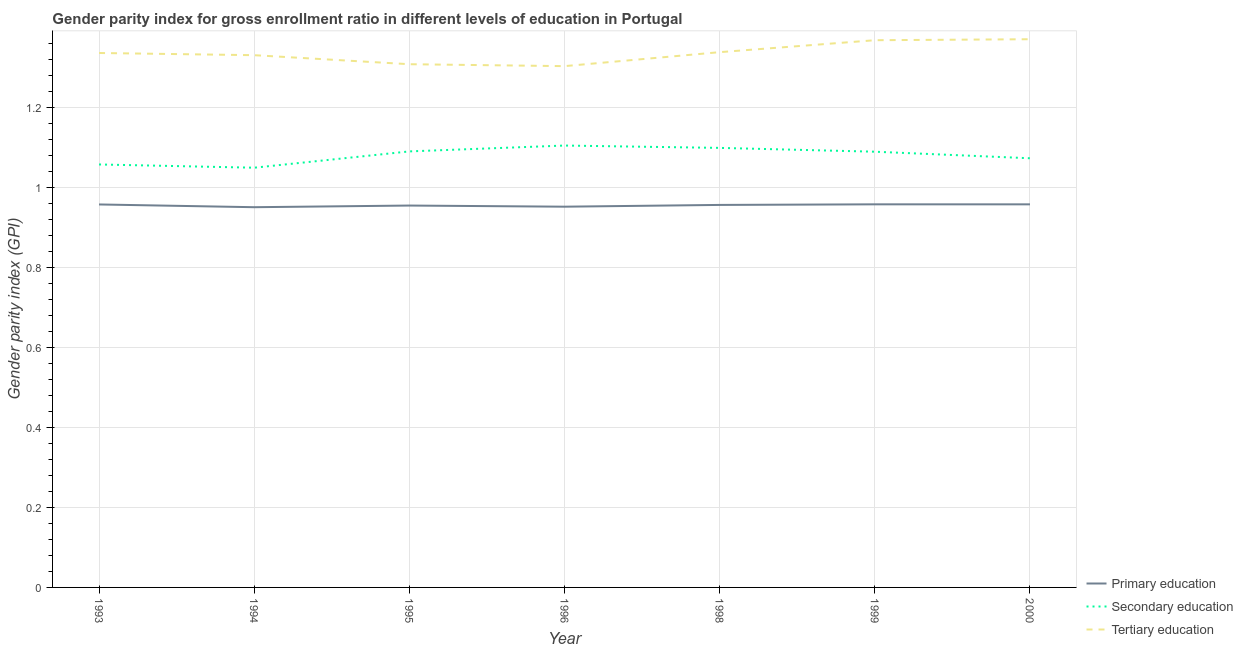How many different coloured lines are there?
Offer a very short reply. 3. Does the line corresponding to gender parity index in secondary education intersect with the line corresponding to gender parity index in tertiary education?
Offer a terse response. No. What is the gender parity index in tertiary education in 1998?
Make the answer very short. 1.34. Across all years, what is the maximum gender parity index in tertiary education?
Offer a terse response. 1.37. Across all years, what is the minimum gender parity index in tertiary education?
Your answer should be very brief. 1.3. In which year was the gender parity index in secondary education minimum?
Offer a very short reply. 1994. What is the total gender parity index in primary education in the graph?
Keep it short and to the point. 6.68. What is the difference between the gender parity index in primary education in 1993 and that in 1995?
Your answer should be compact. 0. What is the difference between the gender parity index in tertiary education in 1999 and the gender parity index in primary education in 1998?
Your response must be concise. 0.41. What is the average gender parity index in secondary education per year?
Make the answer very short. 1.08. In the year 1999, what is the difference between the gender parity index in primary education and gender parity index in secondary education?
Provide a succinct answer. -0.13. In how many years, is the gender parity index in secondary education greater than 0.4?
Provide a succinct answer. 7. What is the ratio of the gender parity index in secondary education in 1993 to that in 2000?
Offer a very short reply. 0.99. Is the difference between the gender parity index in tertiary education in 1994 and 1999 greater than the difference between the gender parity index in primary education in 1994 and 1999?
Provide a short and direct response. No. What is the difference between the highest and the second highest gender parity index in primary education?
Offer a very short reply. 1.0013580321932558e-5. What is the difference between the highest and the lowest gender parity index in secondary education?
Provide a succinct answer. 0.06. In how many years, is the gender parity index in primary education greater than the average gender parity index in primary education taken over all years?
Offer a very short reply. 4. Is the gender parity index in tertiary education strictly greater than the gender parity index in secondary education over the years?
Offer a very short reply. Yes. How many lines are there?
Your response must be concise. 3. Does the graph contain any zero values?
Offer a terse response. No. Does the graph contain grids?
Give a very brief answer. Yes. What is the title of the graph?
Provide a short and direct response. Gender parity index for gross enrollment ratio in different levels of education in Portugal. What is the label or title of the X-axis?
Ensure brevity in your answer.  Year. What is the label or title of the Y-axis?
Give a very brief answer. Gender parity index (GPI). What is the Gender parity index (GPI) in Primary education in 1993?
Ensure brevity in your answer.  0.96. What is the Gender parity index (GPI) in Secondary education in 1993?
Your response must be concise. 1.06. What is the Gender parity index (GPI) of Tertiary education in 1993?
Give a very brief answer. 1.34. What is the Gender parity index (GPI) of Primary education in 1994?
Give a very brief answer. 0.95. What is the Gender parity index (GPI) of Secondary education in 1994?
Offer a very short reply. 1.05. What is the Gender parity index (GPI) in Tertiary education in 1994?
Ensure brevity in your answer.  1.33. What is the Gender parity index (GPI) of Primary education in 1995?
Offer a very short reply. 0.95. What is the Gender parity index (GPI) of Secondary education in 1995?
Offer a terse response. 1.09. What is the Gender parity index (GPI) of Tertiary education in 1995?
Your answer should be compact. 1.31. What is the Gender parity index (GPI) of Primary education in 1996?
Give a very brief answer. 0.95. What is the Gender parity index (GPI) of Secondary education in 1996?
Your answer should be very brief. 1.1. What is the Gender parity index (GPI) in Tertiary education in 1996?
Ensure brevity in your answer.  1.3. What is the Gender parity index (GPI) in Primary education in 1998?
Make the answer very short. 0.96. What is the Gender parity index (GPI) of Secondary education in 1998?
Keep it short and to the point. 1.1. What is the Gender parity index (GPI) of Tertiary education in 1998?
Your response must be concise. 1.34. What is the Gender parity index (GPI) in Primary education in 1999?
Make the answer very short. 0.96. What is the Gender parity index (GPI) in Secondary education in 1999?
Offer a terse response. 1.09. What is the Gender parity index (GPI) in Tertiary education in 1999?
Give a very brief answer. 1.37. What is the Gender parity index (GPI) of Primary education in 2000?
Your answer should be very brief. 0.96. What is the Gender parity index (GPI) of Secondary education in 2000?
Provide a succinct answer. 1.07. What is the Gender parity index (GPI) of Tertiary education in 2000?
Your answer should be very brief. 1.37. Across all years, what is the maximum Gender parity index (GPI) of Primary education?
Provide a succinct answer. 0.96. Across all years, what is the maximum Gender parity index (GPI) in Secondary education?
Provide a short and direct response. 1.1. Across all years, what is the maximum Gender parity index (GPI) of Tertiary education?
Provide a succinct answer. 1.37. Across all years, what is the minimum Gender parity index (GPI) of Primary education?
Your answer should be very brief. 0.95. Across all years, what is the minimum Gender parity index (GPI) in Secondary education?
Your answer should be very brief. 1.05. Across all years, what is the minimum Gender parity index (GPI) of Tertiary education?
Offer a very short reply. 1.3. What is the total Gender parity index (GPI) of Primary education in the graph?
Keep it short and to the point. 6.68. What is the total Gender parity index (GPI) of Secondary education in the graph?
Make the answer very short. 7.56. What is the total Gender parity index (GPI) of Tertiary education in the graph?
Your answer should be very brief. 9.35. What is the difference between the Gender parity index (GPI) in Primary education in 1993 and that in 1994?
Your answer should be very brief. 0.01. What is the difference between the Gender parity index (GPI) of Secondary education in 1993 and that in 1994?
Offer a terse response. 0.01. What is the difference between the Gender parity index (GPI) of Tertiary education in 1993 and that in 1994?
Offer a very short reply. 0.01. What is the difference between the Gender parity index (GPI) of Primary education in 1993 and that in 1995?
Make the answer very short. 0. What is the difference between the Gender parity index (GPI) of Secondary education in 1993 and that in 1995?
Make the answer very short. -0.03. What is the difference between the Gender parity index (GPI) of Tertiary education in 1993 and that in 1995?
Ensure brevity in your answer.  0.03. What is the difference between the Gender parity index (GPI) in Primary education in 1993 and that in 1996?
Ensure brevity in your answer.  0.01. What is the difference between the Gender parity index (GPI) of Secondary education in 1993 and that in 1996?
Your answer should be compact. -0.05. What is the difference between the Gender parity index (GPI) of Tertiary education in 1993 and that in 1996?
Give a very brief answer. 0.03. What is the difference between the Gender parity index (GPI) of Primary education in 1993 and that in 1998?
Give a very brief answer. 0. What is the difference between the Gender parity index (GPI) of Secondary education in 1993 and that in 1998?
Your response must be concise. -0.04. What is the difference between the Gender parity index (GPI) in Tertiary education in 1993 and that in 1998?
Ensure brevity in your answer.  -0. What is the difference between the Gender parity index (GPI) of Primary education in 1993 and that in 1999?
Provide a succinct answer. -0. What is the difference between the Gender parity index (GPI) of Secondary education in 1993 and that in 1999?
Keep it short and to the point. -0.03. What is the difference between the Gender parity index (GPI) in Tertiary education in 1993 and that in 1999?
Offer a very short reply. -0.03. What is the difference between the Gender parity index (GPI) in Primary education in 1993 and that in 2000?
Ensure brevity in your answer.  -0. What is the difference between the Gender parity index (GPI) of Secondary education in 1993 and that in 2000?
Offer a terse response. -0.02. What is the difference between the Gender parity index (GPI) in Tertiary education in 1993 and that in 2000?
Your response must be concise. -0.03. What is the difference between the Gender parity index (GPI) of Primary education in 1994 and that in 1995?
Ensure brevity in your answer.  -0. What is the difference between the Gender parity index (GPI) of Secondary education in 1994 and that in 1995?
Provide a short and direct response. -0.04. What is the difference between the Gender parity index (GPI) in Tertiary education in 1994 and that in 1995?
Keep it short and to the point. 0.02. What is the difference between the Gender parity index (GPI) of Primary education in 1994 and that in 1996?
Provide a succinct answer. -0. What is the difference between the Gender parity index (GPI) in Secondary education in 1994 and that in 1996?
Keep it short and to the point. -0.06. What is the difference between the Gender parity index (GPI) in Tertiary education in 1994 and that in 1996?
Your answer should be compact. 0.03. What is the difference between the Gender parity index (GPI) in Primary education in 1994 and that in 1998?
Keep it short and to the point. -0.01. What is the difference between the Gender parity index (GPI) of Secondary education in 1994 and that in 1998?
Your response must be concise. -0.05. What is the difference between the Gender parity index (GPI) in Tertiary education in 1994 and that in 1998?
Make the answer very short. -0.01. What is the difference between the Gender parity index (GPI) of Primary education in 1994 and that in 1999?
Ensure brevity in your answer.  -0.01. What is the difference between the Gender parity index (GPI) of Secondary education in 1994 and that in 1999?
Your answer should be compact. -0.04. What is the difference between the Gender parity index (GPI) of Tertiary education in 1994 and that in 1999?
Ensure brevity in your answer.  -0.04. What is the difference between the Gender parity index (GPI) of Primary education in 1994 and that in 2000?
Your response must be concise. -0.01. What is the difference between the Gender parity index (GPI) in Secondary education in 1994 and that in 2000?
Make the answer very short. -0.02. What is the difference between the Gender parity index (GPI) of Tertiary education in 1994 and that in 2000?
Provide a succinct answer. -0.04. What is the difference between the Gender parity index (GPI) of Primary education in 1995 and that in 1996?
Offer a terse response. 0. What is the difference between the Gender parity index (GPI) of Secondary education in 1995 and that in 1996?
Offer a very short reply. -0.01. What is the difference between the Gender parity index (GPI) of Tertiary education in 1995 and that in 1996?
Offer a very short reply. 0. What is the difference between the Gender parity index (GPI) in Primary education in 1995 and that in 1998?
Provide a succinct answer. -0. What is the difference between the Gender parity index (GPI) of Secondary education in 1995 and that in 1998?
Ensure brevity in your answer.  -0.01. What is the difference between the Gender parity index (GPI) in Tertiary education in 1995 and that in 1998?
Your answer should be compact. -0.03. What is the difference between the Gender parity index (GPI) of Primary education in 1995 and that in 1999?
Keep it short and to the point. -0. What is the difference between the Gender parity index (GPI) of Secondary education in 1995 and that in 1999?
Ensure brevity in your answer.  0. What is the difference between the Gender parity index (GPI) of Tertiary education in 1995 and that in 1999?
Give a very brief answer. -0.06. What is the difference between the Gender parity index (GPI) in Primary education in 1995 and that in 2000?
Your answer should be very brief. -0. What is the difference between the Gender parity index (GPI) of Secondary education in 1995 and that in 2000?
Provide a succinct answer. 0.02. What is the difference between the Gender parity index (GPI) in Tertiary education in 1995 and that in 2000?
Offer a very short reply. -0.06. What is the difference between the Gender parity index (GPI) of Primary education in 1996 and that in 1998?
Your response must be concise. -0. What is the difference between the Gender parity index (GPI) in Secondary education in 1996 and that in 1998?
Provide a short and direct response. 0.01. What is the difference between the Gender parity index (GPI) of Tertiary education in 1996 and that in 1998?
Ensure brevity in your answer.  -0.03. What is the difference between the Gender parity index (GPI) in Primary education in 1996 and that in 1999?
Provide a short and direct response. -0.01. What is the difference between the Gender parity index (GPI) in Secondary education in 1996 and that in 1999?
Your answer should be compact. 0.02. What is the difference between the Gender parity index (GPI) of Tertiary education in 1996 and that in 1999?
Offer a very short reply. -0.06. What is the difference between the Gender parity index (GPI) in Primary education in 1996 and that in 2000?
Offer a very short reply. -0.01. What is the difference between the Gender parity index (GPI) in Secondary education in 1996 and that in 2000?
Your response must be concise. 0.03. What is the difference between the Gender parity index (GPI) of Tertiary education in 1996 and that in 2000?
Keep it short and to the point. -0.07. What is the difference between the Gender parity index (GPI) of Primary education in 1998 and that in 1999?
Ensure brevity in your answer.  -0. What is the difference between the Gender parity index (GPI) in Secondary education in 1998 and that in 1999?
Your response must be concise. 0.01. What is the difference between the Gender parity index (GPI) of Tertiary education in 1998 and that in 1999?
Your answer should be very brief. -0.03. What is the difference between the Gender parity index (GPI) of Primary education in 1998 and that in 2000?
Offer a terse response. -0. What is the difference between the Gender parity index (GPI) in Secondary education in 1998 and that in 2000?
Offer a very short reply. 0.03. What is the difference between the Gender parity index (GPI) in Tertiary education in 1998 and that in 2000?
Your response must be concise. -0.03. What is the difference between the Gender parity index (GPI) in Secondary education in 1999 and that in 2000?
Your answer should be compact. 0.02. What is the difference between the Gender parity index (GPI) of Tertiary education in 1999 and that in 2000?
Your response must be concise. -0. What is the difference between the Gender parity index (GPI) in Primary education in 1993 and the Gender parity index (GPI) in Secondary education in 1994?
Provide a short and direct response. -0.09. What is the difference between the Gender parity index (GPI) of Primary education in 1993 and the Gender parity index (GPI) of Tertiary education in 1994?
Provide a short and direct response. -0.37. What is the difference between the Gender parity index (GPI) of Secondary education in 1993 and the Gender parity index (GPI) of Tertiary education in 1994?
Provide a short and direct response. -0.27. What is the difference between the Gender parity index (GPI) in Primary education in 1993 and the Gender parity index (GPI) in Secondary education in 1995?
Your answer should be compact. -0.13. What is the difference between the Gender parity index (GPI) of Primary education in 1993 and the Gender parity index (GPI) of Tertiary education in 1995?
Make the answer very short. -0.35. What is the difference between the Gender parity index (GPI) of Secondary education in 1993 and the Gender parity index (GPI) of Tertiary education in 1995?
Give a very brief answer. -0.25. What is the difference between the Gender parity index (GPI) in Primary education in 1993 and the Gender parity index (GPI) in Secondary education in 1996?
Your response must be concise. -0.15. What is the difference between the Gender parity index (GPI) of Primary education in 1993 and the Gender parity index (GPI) of Tertiary education in 1996?
Keep it short and to the point. -0.35. What is the difference between the Gender parity index (GPI) in Secondary education in 1993 and the Gender parity index (GPI) in Tertiary education in 1996?
Your answer should be compact. -0.25. What is the difference between the Gender parity index (GPI) in Primary education in 1993 and the Gender parity index (GPI) in Secondary education in 1998?
Your response must be concise. -0.14. What is the difference between the Gender parity index (GPI) in Primary education in 1993 and the Gender parity index (GPI) in Tertiary education in 1998?
Your answer should be very brief. -0.38. What is the difference between the Gender parity index (GPI) in Secondary education in 1993 and the Gender parity index (GPI) in Tertiary education in 1998?
Provide a succinct answer. -0.28. What is the difference between the Gender parity index (GPI) of Primary education in 1993 and the Gender parity index (GPI) of Secondary education in 1999?
Offer a very short reply. -0.13. What is the difference between the Gender parity index (GPI) of Primary education in 1993 and the Gender parity index (GPI) of Tertiary education in 1999?
Offer a very short reply. -0.41. What is the difference between the Gender parity index (GPI) of Secondary education in 1993 and the Gender parity index (GPI) of Tertiary education in 1999?
Your response must be concise. -0.31. What is the difference between the Gender parity index (GPI) in Primary education in 1993 and the Gender parity index (GPI) in Secondary education in 2000?
Provide a short and direct response. -0.12. What is the difference between the Gender parity index (GPI) of Primary education in 1993 and the Gender parity index (GPI) of Tertiary education in 2000?
Your response must be concise. -0.41. What is the difference between the Gender parity index (GPI) of Secondary education in 1993 and the Gender parity index (GPI) of Tertiary education in 2000?
Offer a very short reply. -0.31. What is the difference between the Gender parity index (GPI) in Primary education in 1994 and the Gender parity index (GPI) in Secondary education in 1995?
Ensure brevity in your answer.  -0.14. What is the difference between the Gender parity index (GPI) in Primary education in 1994 and the Gender parity index (GPI) in Tertiary education in 1995?
Your answer should be compact. -0.36. What is the difference between the Gender parity index (GPI) in Secondary education in 1994 and the Gender parity index (GPI) in Tertiary education in 1995?
Keep it short and to the point. -0.26. What is the difference between the Gender parity index (GPI) in Primary education in 1994 and the Gender parity index (GPI) in Secondary education in 1996?
Your answer should be compact. -0.15. What is the difference between the Gender parity index (GPI) in Primary education in 1994 and the Gender parity index (GPI) in Tertiary education in 1996?
Your answer should be very brief. -0.35. What is the difference between the Gender parity index (GPI) in Secondary education in 1994 and the Gender parity index (GPI) in Tertiary education in 1996?
Provide a short and direct response. -0.25. What is the difference between the Gender parity index (GPI) in Primary education in 1994 and the Gender parity index (GPI) in Secondary education in 1998?
Provide a short and direct response. -0.15. What is the difference between the Gender parity index (GPI) in Primary education in 1994 and the Gender parity index (GPI) in Tertiary education in 1998?
Your answer should be compact. -0.39. What is the difference between the Gender parity index (GPI) of Secondary education in 1994 and the Gender parity index (GPI) of Tertiary education in 1998?
Make the answer very short. -0.29. What is the difference between the Gender parity index (GPI) in Primary education in 1994 and the Gender parity index (GPI) in Secondary education in 1999?
Keep it short and to the point. -0.14. What is the difference between the Gender parity index (GPI) in Primary education in 1994 and the Gender parity index (GPI) in Tertiary education in 1999?
Provide a succinct answer. -0.42. What is the difference between the Gender parity index (GPI) of Secondary education in 1994 and the Gender parity index (GPI) of Tertiary education in 1999?
Keep it short and to the point. -0.32. What is the difference between the Gender parity index (GPI) of Primary education in 1994 and the Gender parity index (GPI) of Secondary education in 2000?
Offer a terse response. -0.12. What is the difference between the Gender parity index (GPI) of Primary education in 1994 and the Gender parity index (GPI) of Tertiary education in 2000?
Offer a terse response. -0.42. What is the difference between the Gender parity index (GPI) of Secondary education in 1994 and the Gender parity index (GPI) of Tertiary education in 2000?
Provide a succinct answer. -0.32. What is the difference between the Gender parity index (GPI) in Primary education in 1995 and the Gender parity index (GPI) in Secondary education in 1996?
Give a very brief answer. -0.15. What is the difference between the Gender parity index (GPI) of Primary education in 1995 and the Gender parity index (GPI) of Tertiary education in 1996?
Keep it short and to the point. -0.35. What is the difference between the Gender parity index (GPI) in Secondary education in 1995 and the Gender parity index (GPI) in Tertiary education in 1996?
Provide a succinct answer. -0.21. What is the difference between the Gender parity index (GPI) in Primary education in 1995 and the Gender parity index (GPI) in Secondary education in 1998?
Ensure brevity in your answer.  -0.14. What is the difference between the Gender parity index (GPI) of Primary education in 1995 and the Gender parity index (GPI) of Tertiary education in 1998?
Make the answer very short. -0.38. What is the difference between the Gender parity index (GPI) in Secondary education in 1995 and the Gender parity index (GPI) in Tertiary education in 1998?
Ensure brevity in your answer.  -0.25. What is the difference between the Gender parity index (GPI) of Primary education in 1995 and the Gender parity index (GPI) of Secondary education in 1999?
Your answer should be compact. -0.13. What is the difference between the Gender parity index (GPI) of Primary education in 1995 and the Gender parity index (GPI) of Tertiary education in 1999?
Provide a succinct answer. -0.41. What is the difference between the Gender parity index (GPI) of Secondary education in 1995 and the Gender parity index (GPI) of Tertiary education in 1999?
Give a very brief answer. -0.28. What is the difference between the Gender parity index (GPI) of Primary education in 1995 and the Gender parity index (GPI) of Secondary education in 2000?
Offer a terse response. -0.12. What is the difference between the Gender parity index (GPI) in Primary education in 1995 and the Gender parity index (GPI) in Tertiary education in 2000?
Give a very brief answer. -0.42. What is the difference between the Gender parity index (GPI) of Secondary education in 1995 and the Gender parity index (GPI) of Tertiary education in 2000?
Your answer should be very brief. -0.28. What is the difference between the Gender parity index (GPI) of Primary education in 1996 and the Gender parity index (GPI) of Secondary education in 1998?
Keep it short and to the point. -0.15. What is the difference between the Gender parity index (GPI) in Primary education in 1996 and the Gender parity index (GPI) in Tertiary education in 1998?
Offer a very short reply. -0.39. What is the difference between the Gender parity index (GPI) in Secondary education in 1996 and the Gender parity index (GPI) in Tertiary education in 1998?
Make the answer very short. -0.23. What is the difference between the Gender parity index (GPI) of Primary education in 1996 and the Gender parity index (GPI) of Secondary education in 1999?
Give a very brief answer. -0.14. What is the difference between the Gender parity index (GPI) of Primary education in 1996 and the Gender parity index (GPI) of Tertiary education in 1999?
Offer a terse response. -0.42. What is the difference between the Gender parity index (GPI) in Secondary education in 1996 and the Gender parity index (GPI) in Tertiary education in 1999?
Provide a short and direct response. -0.26. What is the difference between the Gender parity index (GPI) of Primary education in 1996 and the Gender parity index (GPI) of Secondary education in 2000?
Make the answer very short. -0.12. What is the difference between the Gender parity index (GPI) in Primary education in 1996 and the Gender parity index (GPI) in Tertiary education in 2000?
Keep it short and to the point. -0.42. What is the difference between the Gender parity index (GPI) of Secondary education in 1996 and the Gender parity index (GPI) of Tertiary education in 2000?
Your response must be concise. -0.27. What is the difference between the Gender parity index (GPI) of Primary education in 1998 and the Gender parity index (GPI) of Secondary education in 1999?
Offer a very short reply. -0.13. What is the difference between the Gender parity index (GPI) of Primary education in 1998 and the Gender parity index (GPI) of Tertiary education in 1999?
Provide a short and direct response. -0.41. What is the difference between the Gender parity index (GPI) of Secondary education in 1998 and the Gender parity index (GPI) of Tertiary education in 1999?
Offer a terse response. -0.27. What is the difference between the Gender parity index (GPI) in Primary education in 1998 and the Gender parity index (GPI) in Secondary education in 2000?
Offer a terse response. -0.12. What is the difference between the Gender parity index (GPI) in Primary education in 1998 and the Gender parity index (GPI) in Tertiary education in 2000?
Give a very brief answer. -0.41. What is the difference between the Gender parity index (GPI) in Secondary education in 1998 and the Gender parity index (GPI) in Tertiary education in 2000?
Offer a very short reply. -0.27. What is the difference between the Gender parity index (GPI) in Primary education in 1999 and the Gender parity index (GPI) in Secondary education in 2000?
Provide a short and direct response. -0.12. What is the difference between the Gender parity index (GPI) of Primary education in 1999 and the Gender parity index (GPI) of Tertiary education in 2000?
Provide a short and direct response. -0.41. What is the difference between the Gender parity index (GPI) of Secondary education in 1999 and the Gender parity index (GPI) of Tertiary education in 2000?
Keep it short and to the point. -0.28. What is the average Gender parity index (GPI) in Primary education per year?
Provide a succinct answer. 0.95. What is the average Gender parity index (GPI) of Secondary education per year?
Provide a succinct answer. 1.08. What is the average Gender parity index (GPI) in Tertiary education per year?
Offer a very short reply. 1.34. In the year 1993, what is the difference between the Gender parity index (GPI) in Primary education and Gender parity index (GPI) in Secondary education?
Provide a short and direct response. -0.1. In the year 1993, what is the difference between the Gender parity index (GPI) of Primary education and Gender parity index (GPI) of Tertiary education?
Provide a short and direct response. -0.38. In the year 1993, what is the difference between the Gender parity index (GPI) in Secondary education and Gender parity index (GPI) in Tertiary education?
Your answer should be very brief. -0.28. In the year 1994, what is the difference between the Gender parity index (GPI) in Primary education and Gender parity index (GPI) in Secondary education?
Provide a short and direct response. -0.1. In the year 1994, what is the difference between the Gender parity index (GPI) of Primary education and Gender parity index (GPI) of Tertiary education?
Your response must be concise. -0.38. In the year 1994, what is the difference between the Gender parity index (GPI) in Secondary education and Gender parity index (GPI) in Tertiary education?
Offer a terse response. -0.28. In the year 1995, what is the difference between the Gender parity index (GPI) of Primary education and Gender parity index (GPI) of Secondary education?
Your answer should be very brief. -0.14. In the year 1995, what is the difference between the Gender parity index (GPI) of Primary education and Gender parity index (GPI) of Tertiary education?
Make the answer very short. -0.35. In the year 1995, what is the difference between the Gender parity index (GPI) in Secondary education and Gender parity index (GPI) in Tertiary education?
Provide a succinct answer. -0.22. In the year 1996, what is the difference between the Gender parity index (GPI) in Primary education and Gender parity index (GPI) in Secondary education?
Your response must be concise. -0.15. In the year 1996, what is the difference between the Gender parity index (GPI) of Primary education and Gender parity index (GPI) of Tertiary education?
Your response must be concise. -0.35. In the year 1996, what is the difference between the Gender parity index (GPI) of Secondary education and Gender parity index (GPI) of Tertiary education?
Give a very brief answer. -0.2. In the year 1998, what is the difference between the Gender parity index (GPI) of Primary education and Gender parity index (GPI) of Secondary education?
Provide a short and direct response. -0.14. In the year 1998, what is the difference between the Gender parity index (GPI) in Primary education and Gender parity index (GPI) in Tertiary education?
Give a very brief answer. -0.38. In the year 1998, what is the difference between the Gender parity index (GPI) of Secondary education and Gender parity index (GPI) of Tertiary education?
Offer a very short reply. -0.24. In the year 1999, what is the difference between the Gender parity index (GPI) of Primary education and Gender parity index (GPI) of Secondary education?
Make the answer very short. -0.13. In the year 1999, what is the difference between the Gender parity index (GPI) in Primary education and Gender parity index (GPI) in Tertiary education?
Your response must be concise. -0.41. In the year 1999, what is the difference between the Gender parity index (GPI) of Secondary education and Gender parity index (GPI) of Tertiary education?
Your answer should be very brief. -0.28. In the year 2000, what is the difference between the Gender parity index (GPI) in Primary education and Gender parity index (GPI) in Secondary education?
Offer a very short reply. -0.12. In the year 2000, what is the difference between the Gender parity index (GPI) in Primary education and Gender parity index (GPI) in Tertiary education?
Ensure brevity in your answer.  -0.41. In the year 2000, what is the difference between the Gender parity index (GPI) in Secondary education and Gender parity index (GPI) in Tertiary education?
Offer a terse response. -0.3. What is the ratio of the Gender parity index (GPI) of Primary education in 1993 to that in 1994?
Offer a very short reply. 1.01. What is the ratio of the Gender parity index (GPI) of Secondary education in 1993 to that in 1994?
Give a very brief answer. 1.01. What is the ratio of the Gender parity index (GPI) of Tertiary education in 1993 to that in 1994?
Offer a terse response. 1. What is the ratio of the Gender parity index (GPI) of Tertiary education in 1993 to that in 1995?
Offer a terse response. 1.02. What is the ratio of the Gender parity index (GPI) in Primary education in 1993 to that in 1996?
Your answer should be very brief. 1.01. What is the ratio of the Gender parity index (GPI) of Secondary education in 1993 to that in 1996?
Offer a terse response. 0.96. What is the ratio of the Gender parity index (GPI) in Tertiary education in 1993 to that in 1996?
Make the answer very short. 1.03. What is the ratio of the Gender parity index (GPI) in Primary education in 1993 to that in 1998?
Your answer should be compact. 1. What is the ratio of the Gender parity index (GPI) in Secondary education in 1993 to that in 1998?
Provide a succinct answer. 0.96. What is the ratio of the Gender parity index (GPI) in Tertiary education in 1993 to that in 1998?
Your answer should be compact. 1. What is the ratio of the Gender parity index (GPI) of Primary education in 1993 to that in 1999?
Offer a terse response. 1. What is the ratio of the Gender parity index (GPI) of Secondary education in 1993 to that in 1999?
Your response must be concise. 0.97. What is the ratio of the Gender parity index (GPI) in Tertiary education in 1993 to that in 1999?
Offer a terse response. 0.98. What is the ratio of the Gender parity index (GPI) of Secondary education in 1993 to that in 2000?
Offer a very short reply. 0.99. What is the ratio of the Gender parity index (GPI) in Tertiary education in 1993 to that in 2000?
Make the answer very short. 0.97. What is the ratio of the Gender parity index (GPI) of Primary education in 1994 to that in 1995?
Provide a short and direct response. 1. What is the ratio of the Gender parity index (GPI) of Secondary education in 1994 to that in 1995?
Your response must be concise. 0.96. What is the ratio of the Gender parity index (GPI) of Tertiary education in 1994 to that in 1995?
Give a very brief answer. 1.02. What is the ratio of the Gender parity index (GPI) of Primary education in 1994 to that in 1996?
Make the answer very short. 1. What is the ratio of the Gender parity index (GPI) in Secondary education in 1994 to that in 1996?
Ensure brevity in your answer.  0.95. What is the ratio of the Gender parity index (GPI) of Primary education in 1994 to that in 1998?
Make the answer very short. 0.99. What is the ratio of the Gender parity index (GPI) of Secondary education in 1994 to that in 1998?
Your answer should be compact. 0.95. What is the ratio of the Gender parity index (GPI) in Primary education in 1994 to that in 1999?
Your answer should be compact. 0.99. What is the ratio of the Gender parity index (GPI) in Secondary education in 1994 to that in 1999?
Provide a succinct answer. 0.96. What is the ratio of the Gender parity index (GPI) in Tertiary education in 1994 to that in 1999?
Your answer should be very brief. 0.97. What is the ratio of the Gender parity index (GPI) in Secondary education in 1994 to that in 2000?
Provide a succinct answer. 0.98. What is the ratio of the Gender parity index (GPI) in Tertiary education in 1994 to that in 2000?
Your answer should be compact. 0.97. What is the ratio of the Gender parity index (GPI) of Secondary education in 1995 to that in 1996?
Offer a terse response. 0.99. What is the ratio of the Gender parity index (GPI) in Primary education in 1995 to that in 1998?
Offer a very short reply. 1. What is the ratio of the Gender parity index (GPI) in Secondary education in 1995 to that in 1998?
Offer a very short reply. 0.99. What is the ratio of the Gender parity index (GPI) of Tertiary education in 1995 to that in 1998?
Offer a very short reply. 0.98. What is the ratio of the Gender parity index (GPI) in Primary education in 1995 to that in 1999?
Your response must be concise. 1. What is the ratio of the Gender parity index (GPI) of Secondary education in 1995 to that in 1999?
Your response must be concise. 1. What is the ratio of the Gender parity index (GPI) in Tertiary education in 1995 to that in 1999?
Provide a short and direct response. 0.96. What is the ratio of the Gender parity index (GPI) in Secondary education in 1995 to that in 2000?
Provide a succinct answer. 1.02. What is the ratio of the Gender parity index (GPI) in Tertiary education in 1995 to that in 2000?
Provide a succinct answer. 0.95. What is the ratio of the Gender parity index (GPI) of Secondary education in 1996 to that in 1998?
Your answer should be very brief. 1.01. What is the ratio of the Gender parity index (GPI) in Tertiary education in 1996 to that in 1998?
Keep it short and to the point. 0.97. What is the ratio of the Gender parity index (GPI) in Secondary education in 1996 to that in 1999?
Provide a short and direct response. 1.01. What is the ratio of the Gender parity index (GPI) in Tertiary education in 1996 to that in 1999?
Your response must be concise. 0.95. What is the ratio of the Gender parity index (GPI) of Secondary education in 1996 to that in 2000?
Make the answer very short. 1.03. What is the ratio of the Gender parity index (GPI) of Tertiary education in 1996 to that in 2000?
Your answer should be compact. 0.95. What is the ratio of the Gender parity index (GPI) in Primary education in 1998 to that in 1999?
Offer a terse response. 1. What is the ratio of the Gender parity index (GPI) of Secondary education in 1998 to that in 1999?
Provide a succinct answer. 1.01. What is the ratio of the Gender parity index (GPI) in Tertiary education in 1998 to that in 1999?
Your answer should be very brief. 0.98. What is the ratio of the Gender parity index (GPI) of Secondary education in 1998 to that in 2000?
Ensure brevity in your answer.  1.02. What is the ratio of the Gender parity index (GPI) of Tertiary education in 1998 to that in 2000?
Your response must be concise. 0.98. What is the ratio of the Gender parity index (GPI) in Primary education in 1999 to that in 2000?
Keep it short and to the point. 1. What is the ratio of the Gender parity index (GPI) of Secondary education in 1999 to that in 2000?
Offer a very short reply. 1.02. What is the ratio of the Gender parity index (GPI) in Tertiary education in 1999 to that in 2000?
Your answer should be compact. 1. What is the difference between the highest and the second highest Gender parity index (GPI) in Primary education?
Give a very brief answer. 0. What is the difference between the highest and the second highest Gender parity index (GPI) in Secondary education?
Make the answer very short. 0.01. What is the difference between the highest and the second highest Gender parity index (GPI) in Tertiary education?
Make the answer very short. 0. What is the difference between the highest and the lowest Gender parity index (GPI) in Primary education?
Your response must be concise. 0.01. What is the difference between the highest and the lowest Gender parity index (GPI) in Secondary education?
Offer a very short reply. 0.06. What is the difference between the highest and the lowest Gender parity index (GPI) in Tertiary education?
Your answer should be very brief. 0.07. 